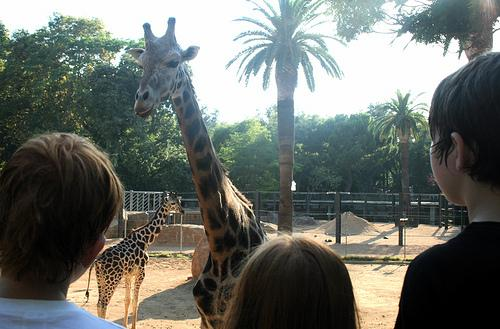How tall is the average newborn giraffe? Please explain your reasoning. 6 feet. Newborn giraffe's are really big. adult giraffe's are even bigger. 